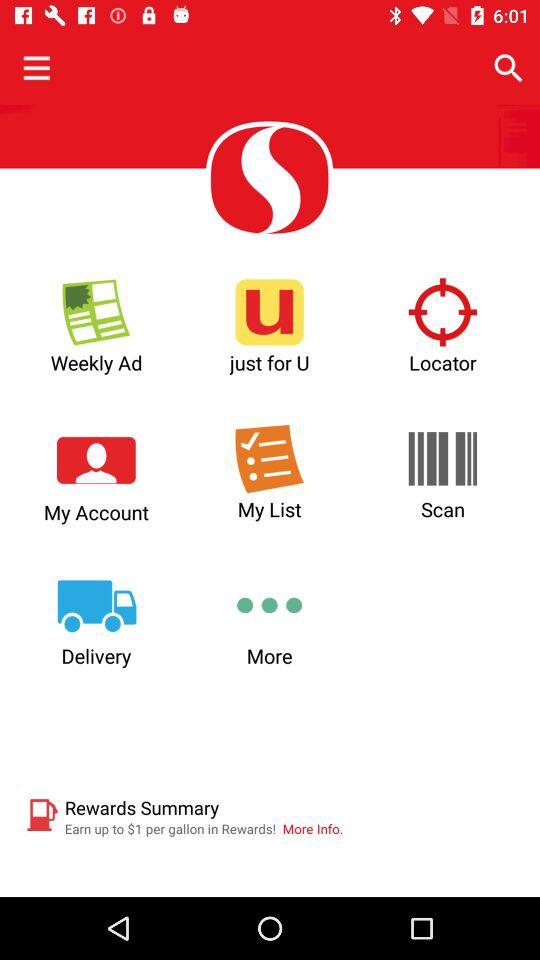How much can we earn in "Rewards"? You can earn up to $1 per gallon in "Rewards". 